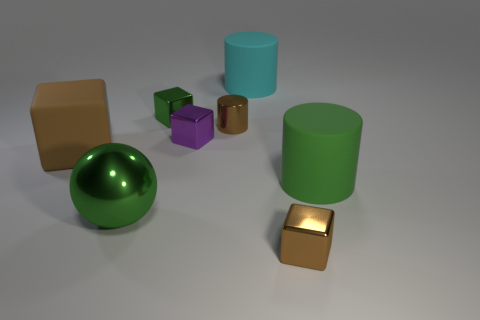Subtract all big brown matte blocks. How many blocks are left? 3 Add 1 metallic cylinders. How many objects exist? 9 Subtract all brown blocks. How many blocks are left? 2 Subtract all cylinders. How many objects are left? 5 Subtract 1 spheres. How many spheres are left? 0 Add 5 big green shiny balls. How many big green shiny balls exist? 6 Subtract 0 gray cylinders. How many objects are left? 8 Subtract all gray blocks. Subtract all purple cylinders. How many blocks are left? 4 Subtract all cyan cylinders. How many yellow cubes are left? 0 Subtract all tiny green blocks. Subtract all tiny cyan rubber cubes. How many objects are left? 7 